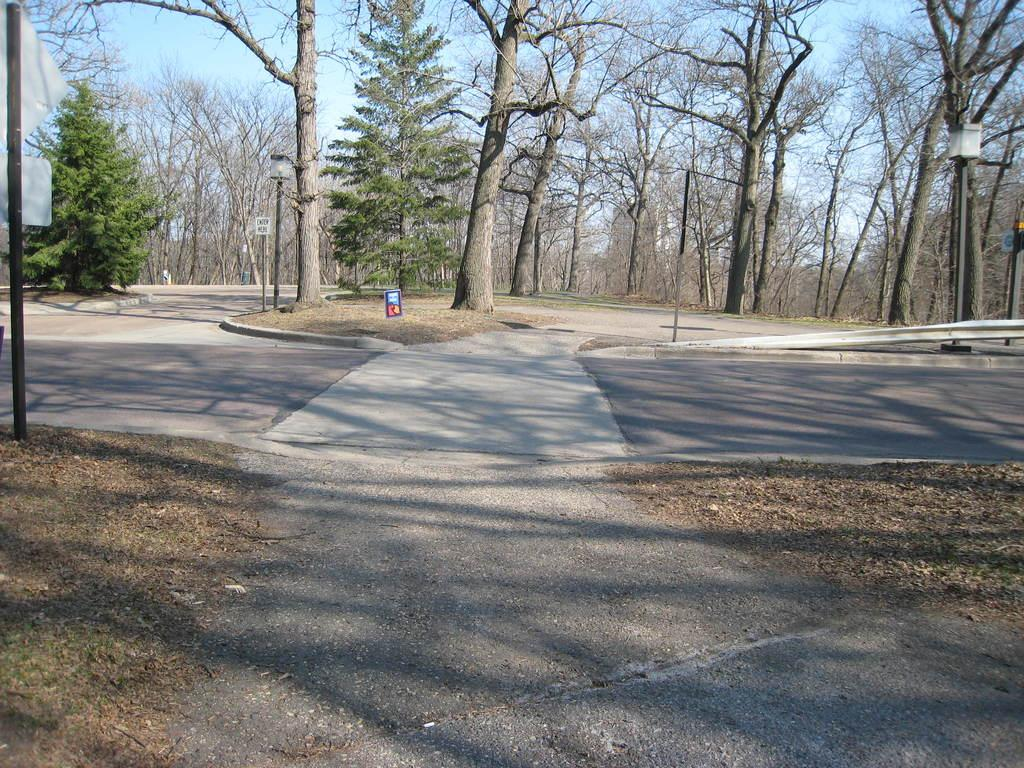What is the main feature of the image? There is a road in the image. What can be seen beside the road? There are trees visible beside the road. What is visible in the background of the image? The sky is visible in the image. What is located on the right side of the image? There is a street light pole on the right side of the image. What type of disgusting animal can be seen crawling on the street light pole in the image? There are no animals, disgusting or otherwise, present on the street light pole in the image. 